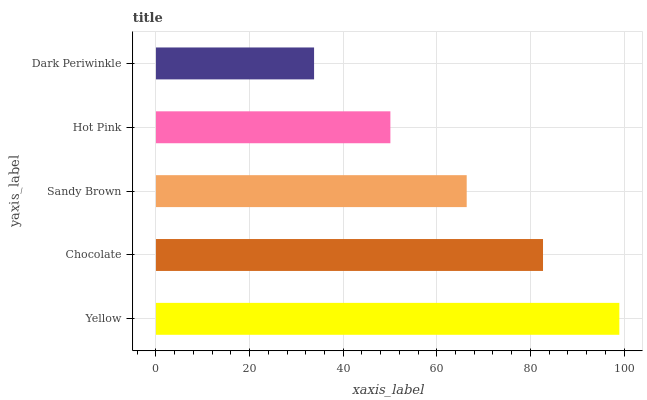Is Dark Periwinkle the minimum?
Answer yes or no. Yes. Is Yellow the maximum?
Answer yes or no. Yes. Is Chocolate the minimum?
Answer yes or no. No. Is Chocolate the maximum?
Answer yes or no. No. Is Yellow greater than Chocolate?
Answer yes or no. Yes. Is Chocolate less than Yellow?
Answer yes or no. Yes. Is Chocolate greater than Yellow?
Answer yes or no. No. Is Yellow less than Chocolate?
Answer yes or no. No. Is Sandy Brown the high median?
Answer yes or no. Yes. Is Sandy Brown the low median?
Answer yes or no. Yes. Is Hot Pink the high median?
Answer yes or no. No. Is Yellow the low median?
Answer yes or no. No. 